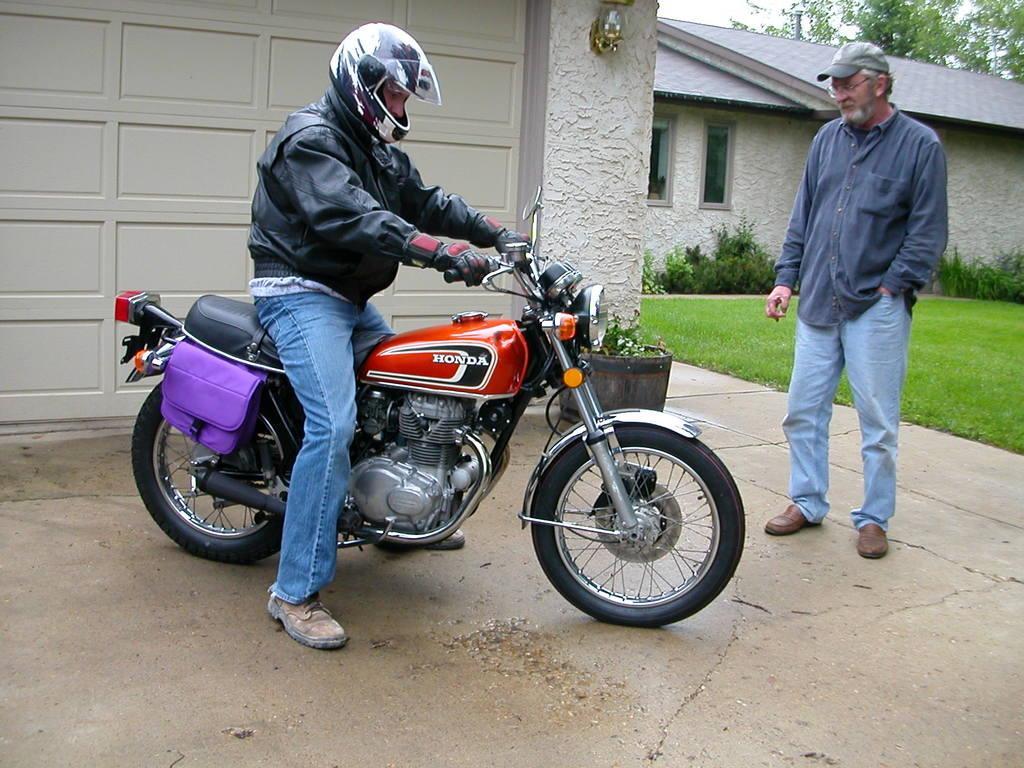How would you summarize this image in a sentence or two? This man wore jacket and helmet is sitting on a motor bike. Beside this motorbike there is a purple bag. This man is standing and wore cap. This is a house with roof top and window. In-front of this house there are plants and grass. This is tree. 